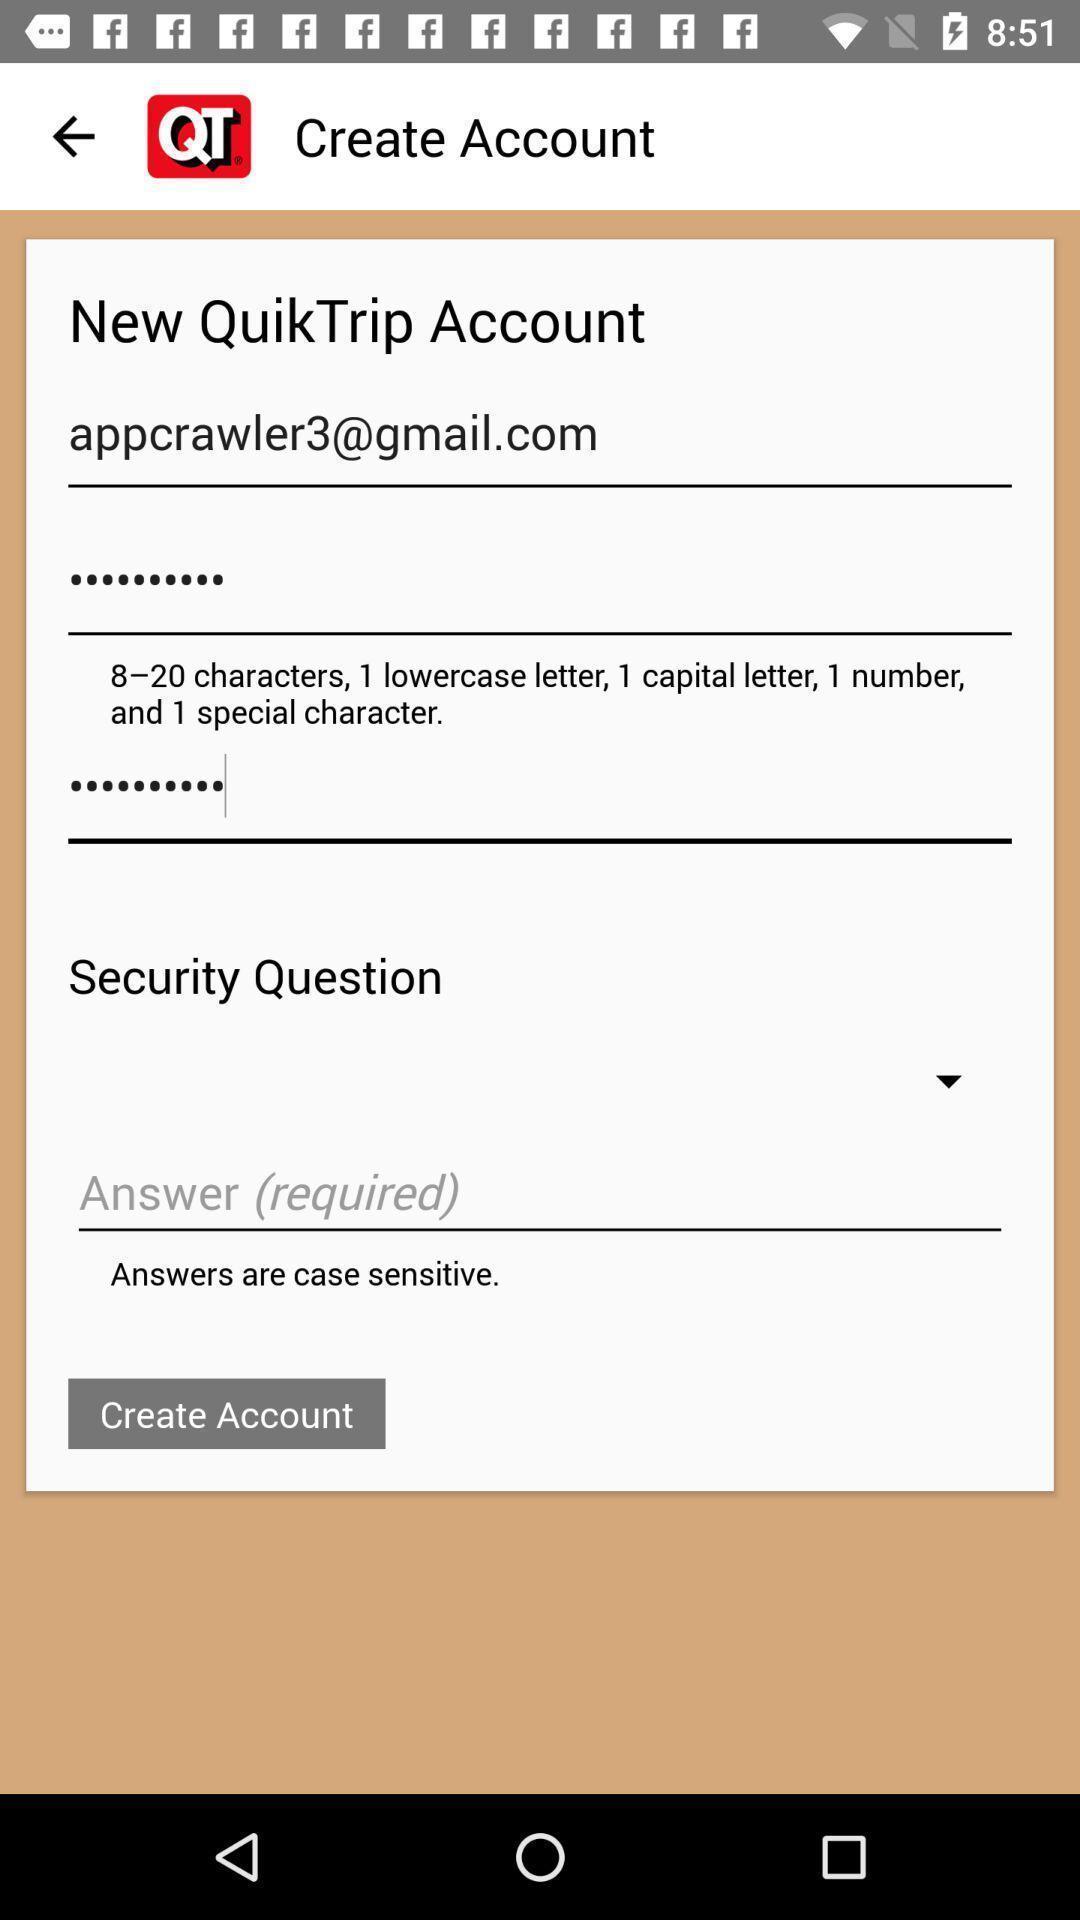Provide a textual representation of this image. Screen displaying user account information in a food application. 